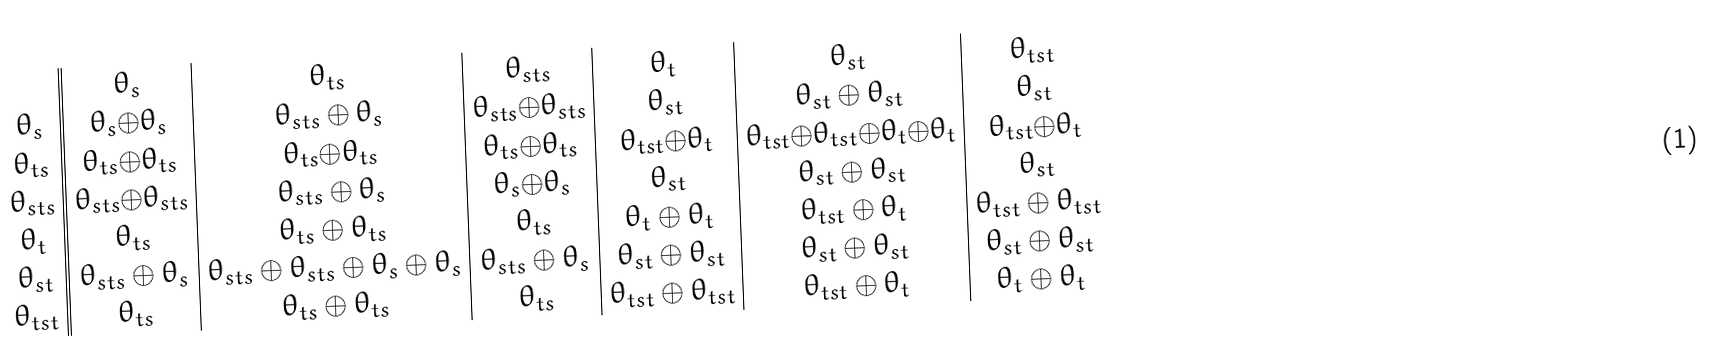<formula> <loc_0><loc_0><loc_500><loc_500>\begin{array} { c | | c | c | c | c | c | c } & \theta _ { s } & \theta _ { t s } & \theta _ { s t s } & \theta _ { t } & \theta _ { s t } & \theta _ { t s t } \\ \theta _ { s } & \theta _ { s } { \oplus } \theta _ { s } & \theta _ { s t s } \oplus \theta _ { s } & \theta _ { s t s } { \oplus } \theta _ { s t s } & \theta _ { s t } & \theta _ { s t } \oplus \theta _ { s t } & \theta _ { s t } \\ \theta _ { t s } & \theta _ { t s } { \oplus } \theta _ { t s } & \theta _ { t s } { \oplus } \theta _ { t s } & \theta _ { t s } { \oplus } \theta _ { t s } & \theta _ { t s t } { \oplus } \theta _ { t } & \theta _ { t s t } { \oplus } \theta _ { t s t } { \oplus } \theta _ { t } { \oplus } \theta _ { t } & \theta _ { t s t } { \oplus } \theta _ { t } \\ \theta _ { s t s } & \theta _ { s t s } { \oplus } \theta _ { s t s } & \theta _ { s t s } \oplus \theta _ { s } & \theta _ { s } { \oplus } \theta _ { s } & \theta _ { s t } & \theta _ { s t } \oplus \theta _ { s t } & \theta _ { s t } \\ \theta _ { t } & \theta _ { t s } & \theta _ { t s } \oplus \theta _ { t s } & \theta _ { t s } & \theta _ { t } \oplus \theta _ { t } & \theta _ { t s t } \oplus \theta _ { t } & \theta _ { t s t } \oplus \theta _ { t s t } \\ \theta _ { s t } & \theta _ { s t s } \oplus \theta _ { s } & \theta _ { s t s } \oplus \theta _ { s t s } \oplus \theta _ { s } \oplus \theta _ { s } & \theta _ { s t s } \oplus \theta _ { s } & \theta _ { s t } \oplus \theta _ { s t } & \theta _ { s t } \oplus \theta _ { s t } & \theta _ { s t } \oplus \theta _ { s t } \\ \theta _ { t s t } & \theta _ { t s } & \theta _ { t s } \oplus \theta _ { t s } & \theta _ { t s } & \theta _ { t s t } \oplus \theta _ { t s t } & \theta _ { t s t } \oplus \theta _ { t } & \theta _ { t } \oplus \theta _ { t } \\ \end{array}</formula> 